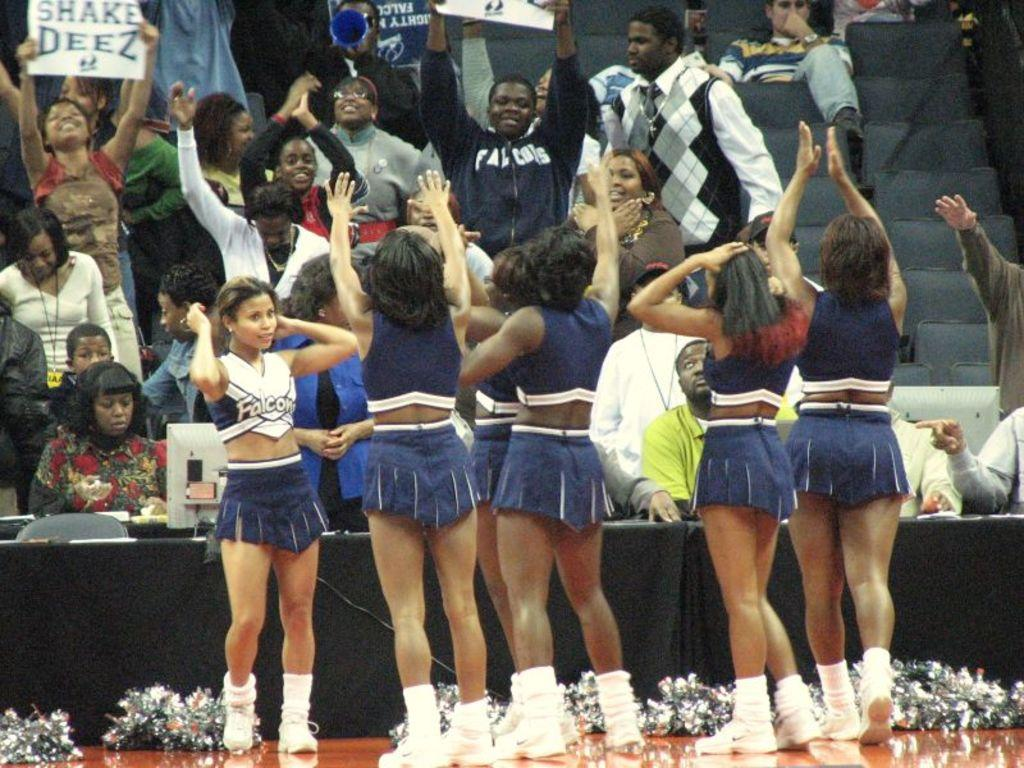Provide a one-sentence caption for the provided image. A group of cheerleaders perform before a crowd at a Falcons game. 